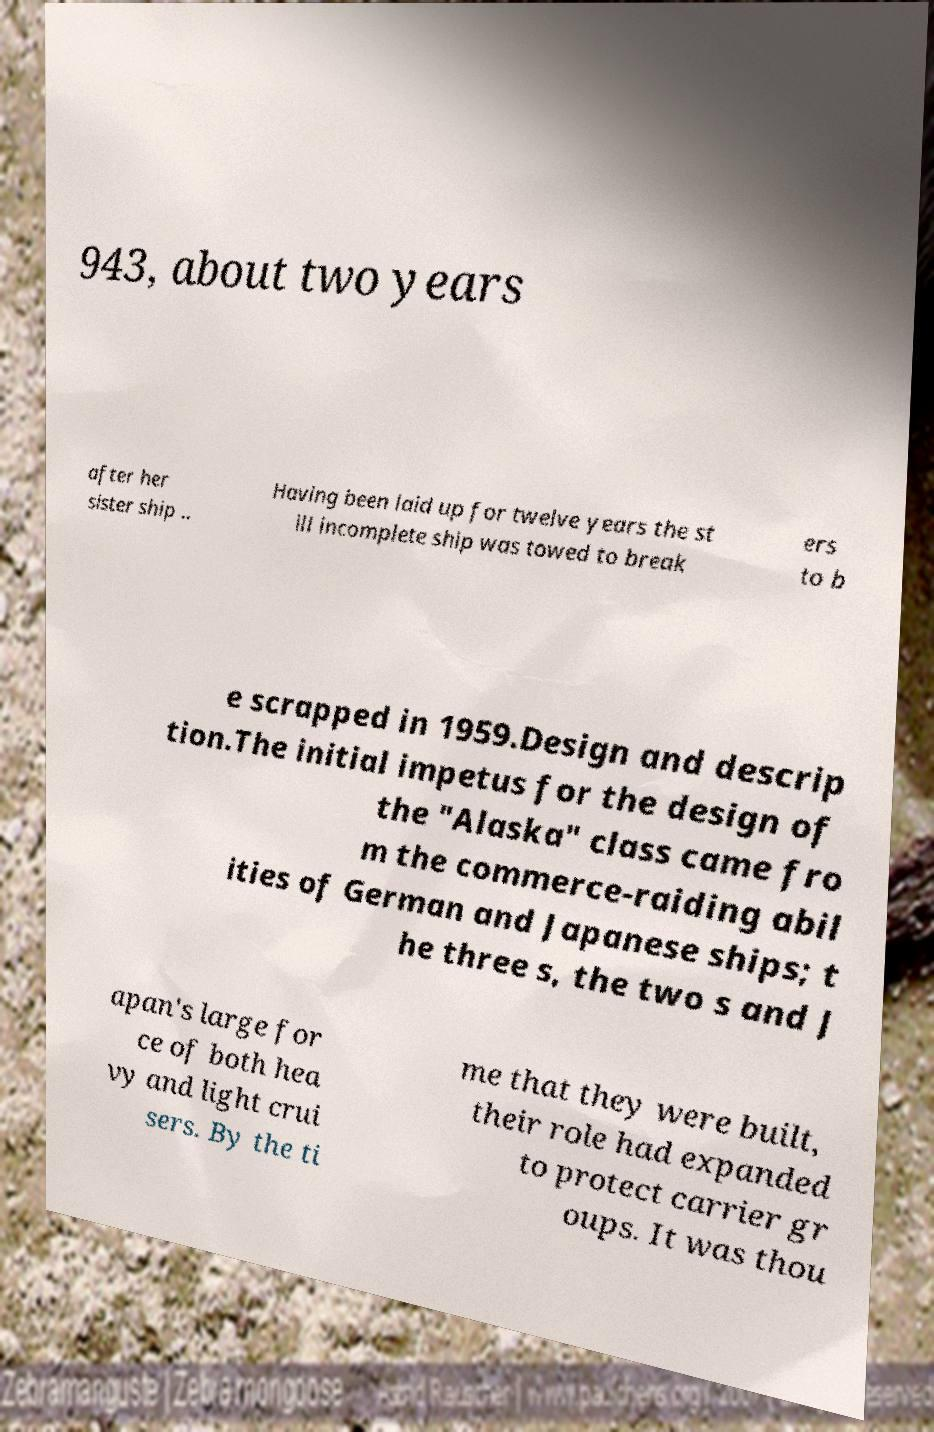For documentation purposes, I need the text within this image transcribed. Could you provide that? 943, about two years after her sister ship .. Having been laid up for twelve years the st ill incomplete ship was towed to break ers to b e scrapped in 1959.Design and descrip tion.The initial impetus for the design of the "Alaska" class came fro m the commerce-raiding abil ities of German and Japanese ships; t he three s, the two s and J apan's large for ce of both hea vy and light crui sers. By the ti me that they were built, their role had expanded to protect carrier gr oups. It was thou 